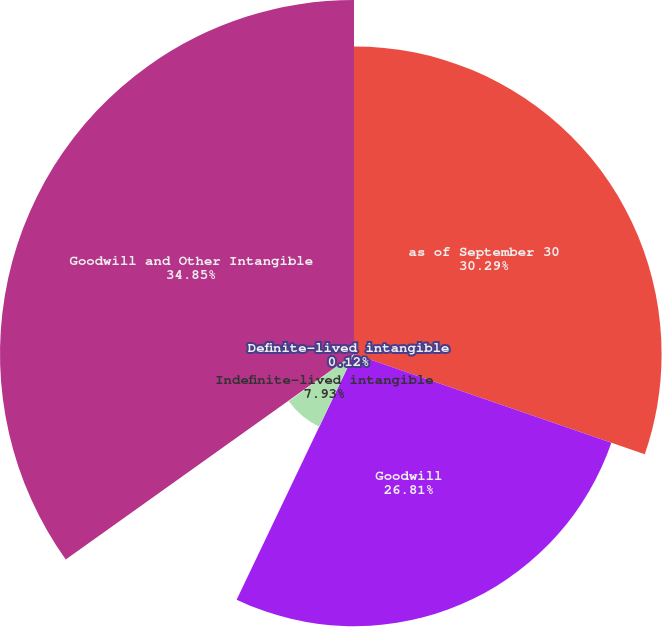Convert chart to OTSL. <chart><loc_0><loc_0><loc_500><loc_500><pie_chart><fcel>as of September 30<fcel>Goodwill<fcel>Indefinite-lived intangible<fcel>Definite-lived intangible<fcel>Goodwill and Other Intangible<nl><fcel>30.29%<fcel>26.81%<fcel>7.93%<fcel>0.12%<fcel>34.86%<nl></chart> 